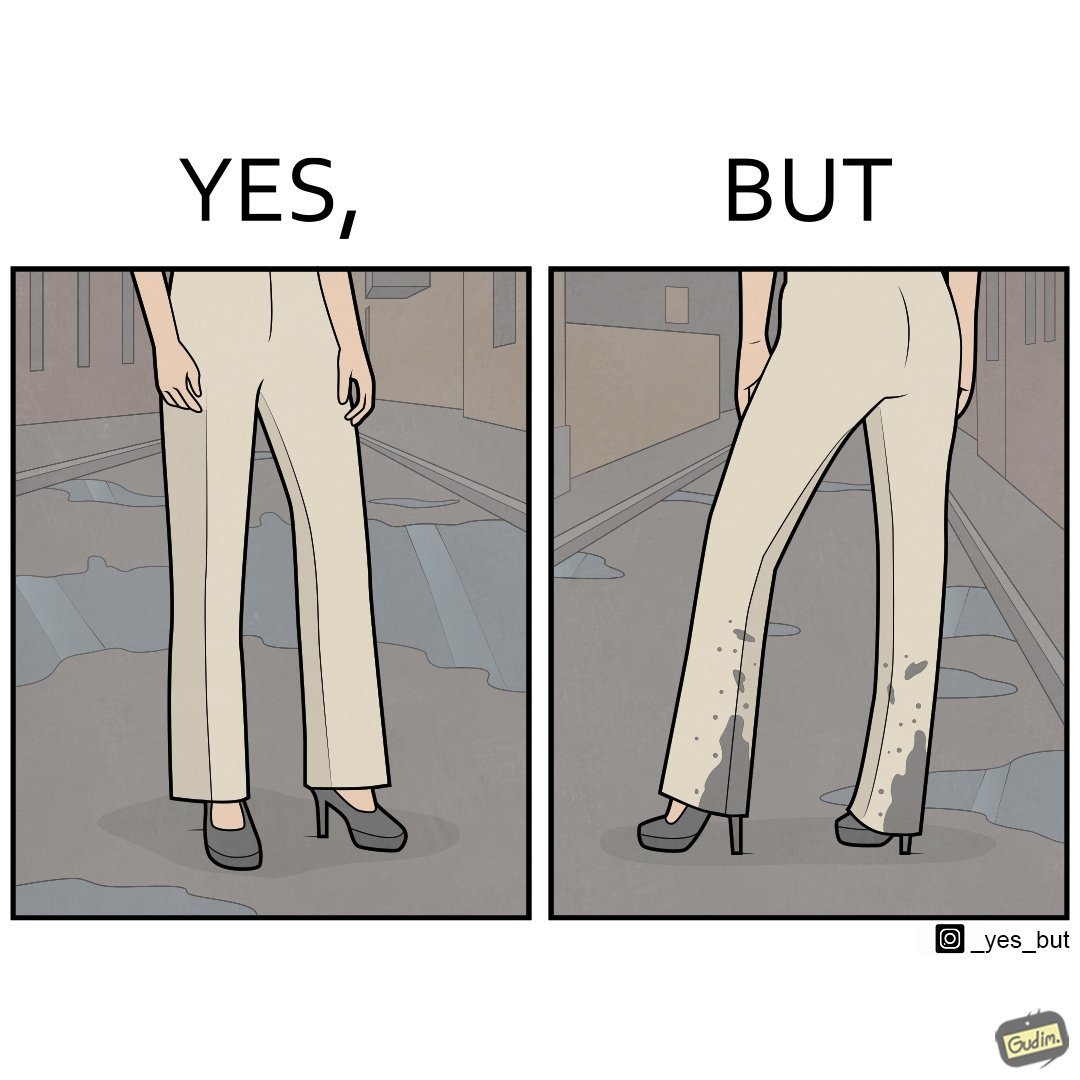What is the satirical meaning behind this image? The image is funny, as when looking from the front, girl's pants are spick and span, while looking from the back, her pants are soaked in water, probably due to walking on a road filled with water in high heels. This is ironical, as the very reason for wearing heels (i.e. looking beautiful) is defeated, due to the heels themselves. 